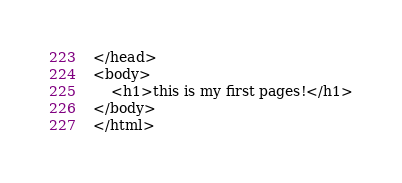<code> <loc_0><loc_0><loc_500><loc_500><_HTML_></head>
<body>
	<h1>this is my first pages!</h1>
</body>
</html></code> 